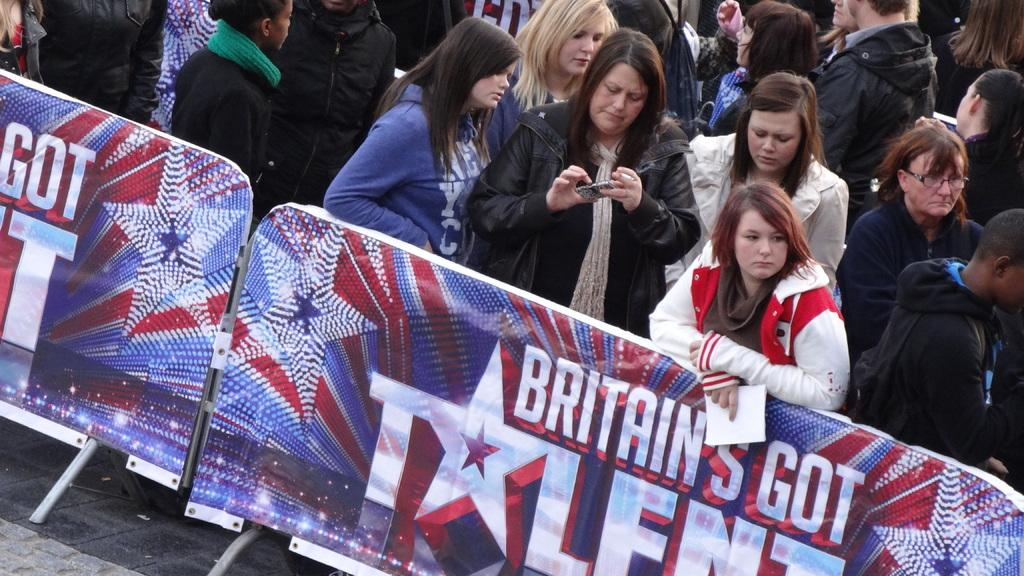What can be seen in the image involving people? There are people standing in the image. What objects are on the floor in the image? There are two boards with banners on the floor. What are some people doing in the image? Some people are holding objects in the image. What information is present on the banners? There is text and images on the banners. What type of advertisement can be seen on the rail in the image? There is no rail present in the image, and therefore no advertisement can be seen on it. 